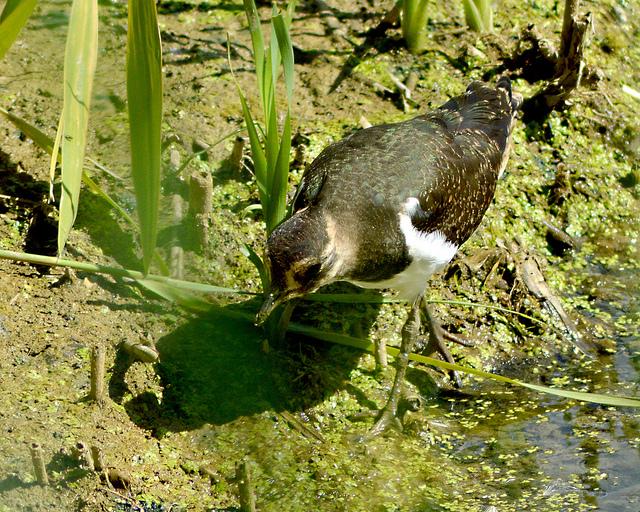What animal is this?
Be succinct. Bird. What is in the birds mouth?
Keep it brief. Grass. Is the water fairly clear?
Be succinct. Yes. 